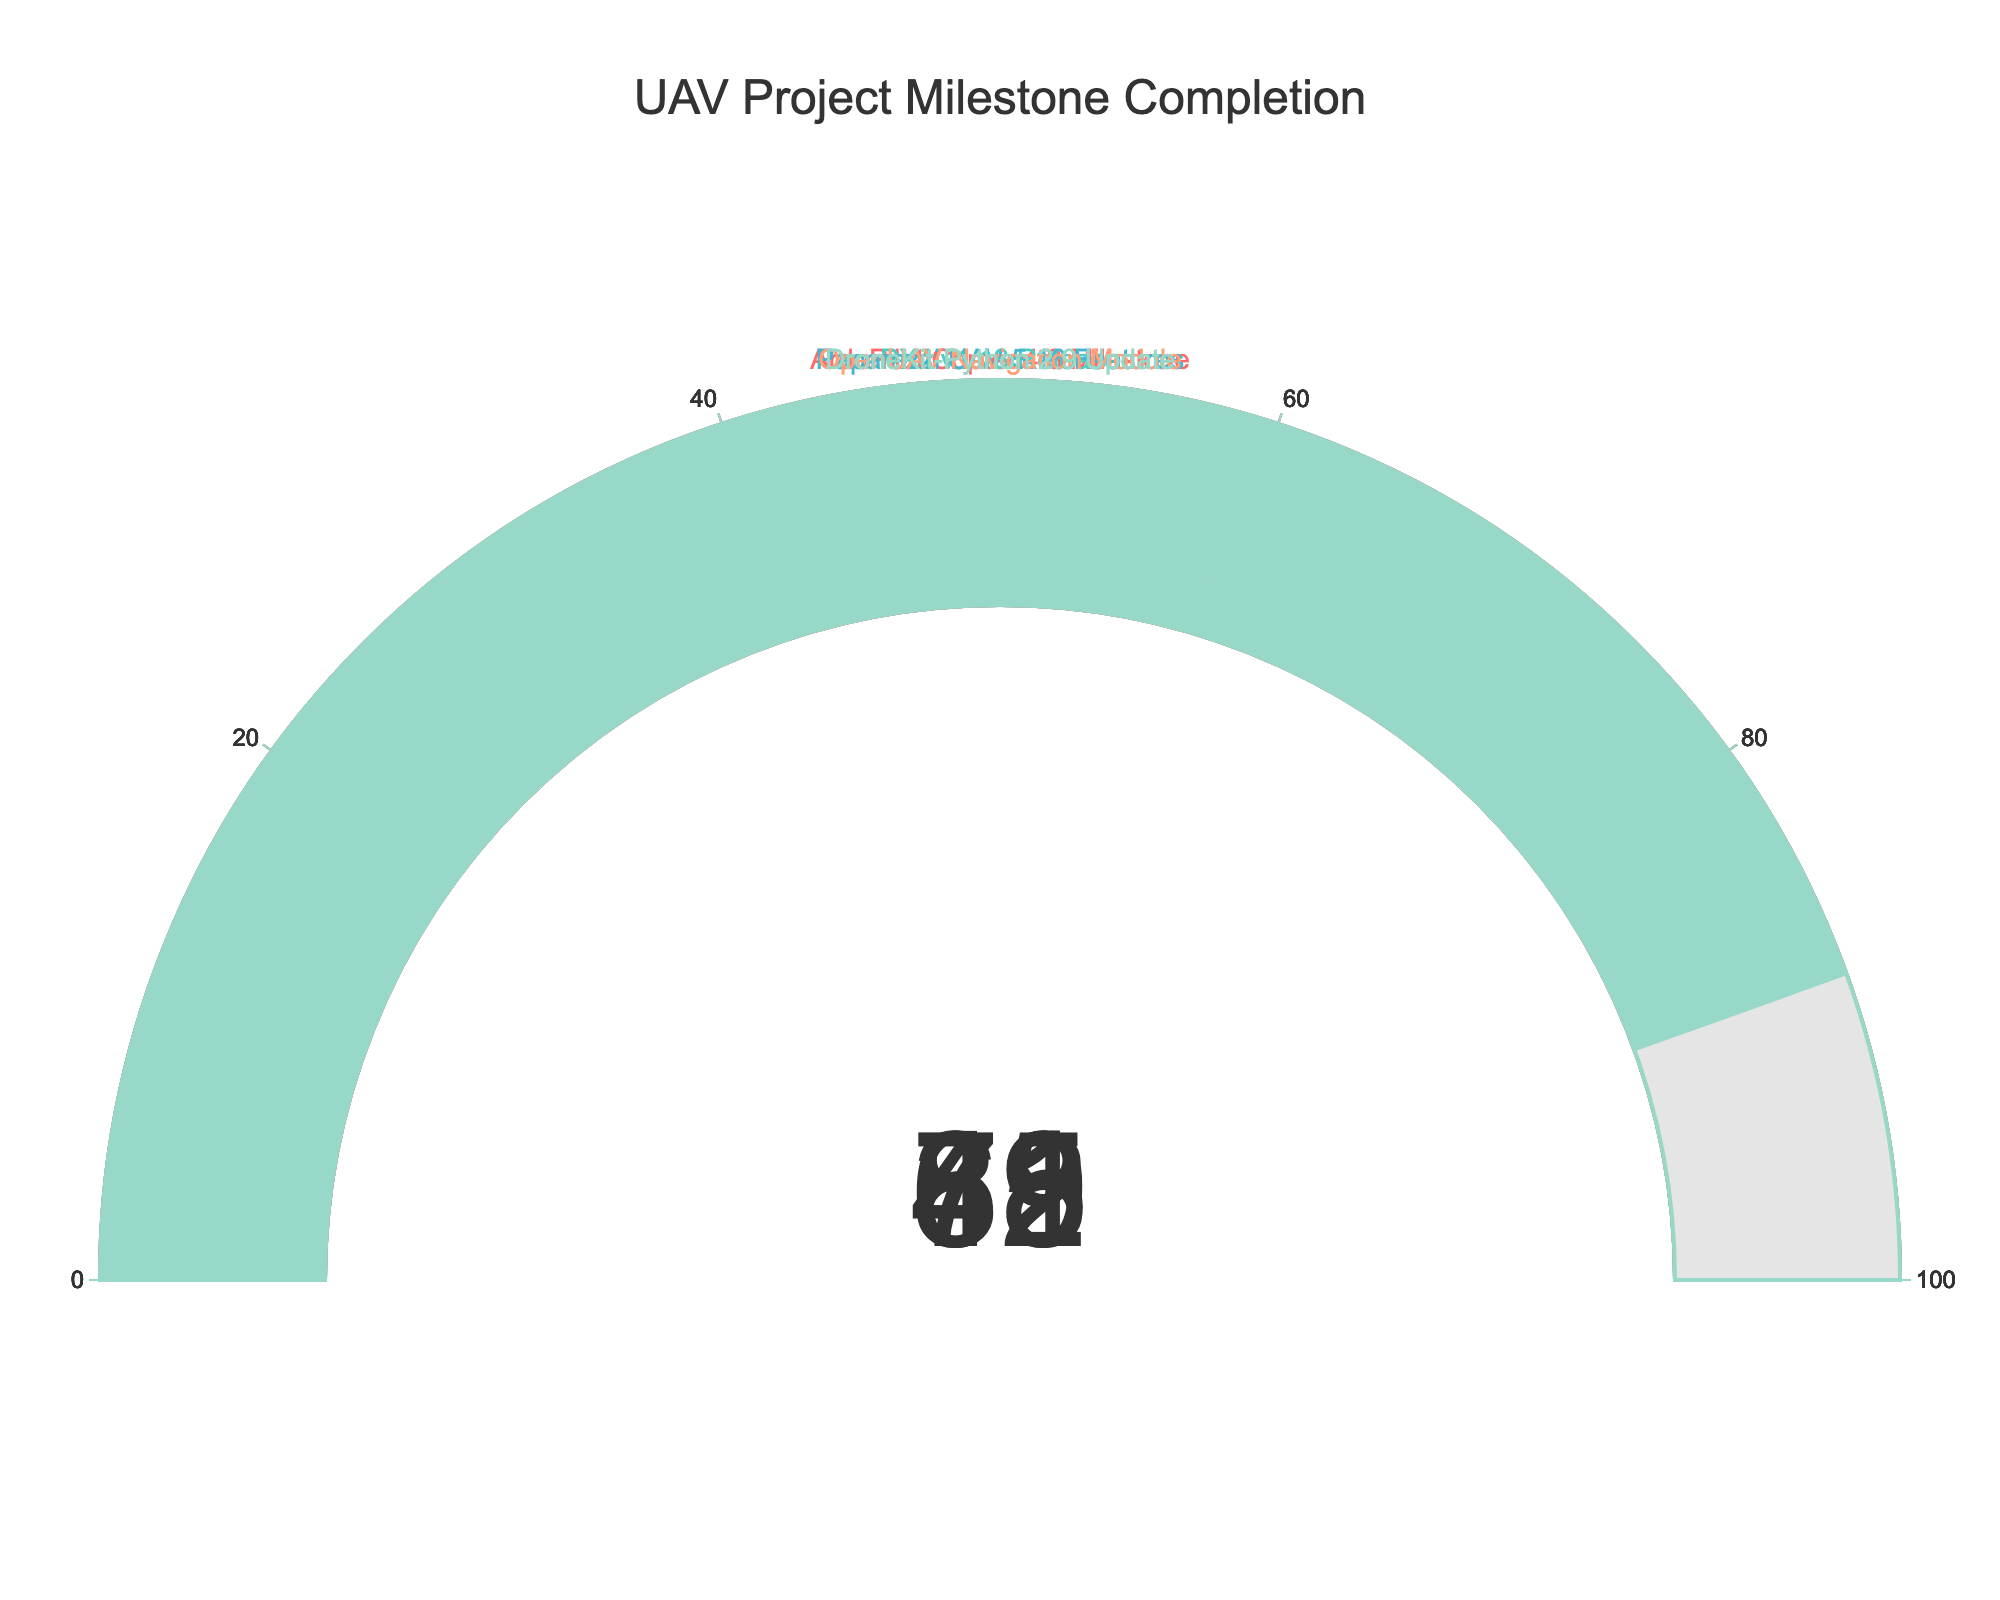What is the title of the figure? The title is usually located at the top of the figure and provides a clear summary of the visualized data. Here, the title is "UAV Project Milestone Completion".
Answer: UAV Project Milestone Completion Which project has the highest completion percentage? By looking at each gauge, we can see the numbers presented. The project with the highest value is "DroneKit-Python 2.9 Update" at 89%.
Answer: DroneKit-Python 2.9 Update What is the completion percentage of the OpenUAV Navigation Module? By locating the gauge that represents the "OpenUAV Navigation Module", we can read the completion percentage displayed on it.
Answer: 31% What is the average completion percentage of all projects? First, sum the completion percentages: 78 + 65 + 42 + 31 + 89 = 305. Then divide by the number of projects, which is 5. The average is 305 / 5 = 61.
Answer: 61 Which project has the lowest completion percentage, and what is the percentage? By comparing the completion values on all the gauges, we find that "OpenUAV Navigation Module" has the lowest value, which is 31%.
Answer: OpenUAV Navigation Module, 31% How many projects have a completion percentage higher than 70%? Identifying the projects by their percentage, we see that "ArduPilot Copter 4.3 Milestone" and "DroneKit-Python 2.9 Update" are the only two projects above 70%.
Answer: 2 What is the difference in completion percentage between PX4 v1.13 Release and Paparazzi UAV 5.16 Features? PX4 v1.13 Release has a completion of 65%, and Paparazzi UAV 5.16 Features has 42%. The difference is 65 - 42 = 23.
Answer: 23 If the average completion percentage for the projects is targeted at 60%, which projects are below this target? The projects below 60% completion are PX4 v1.13 Release (65%), Paparazzi UAV 5.16 Features (42%), and OpenUAV Navigation Module (31%). Therefore, the projects below the target (60%) are Paparazzi UAV 5.16 Features and OpenUAV Navigation Module.
Answer: Paparazzi UAV 5.16 Features, OpenUAV Navigation Module 